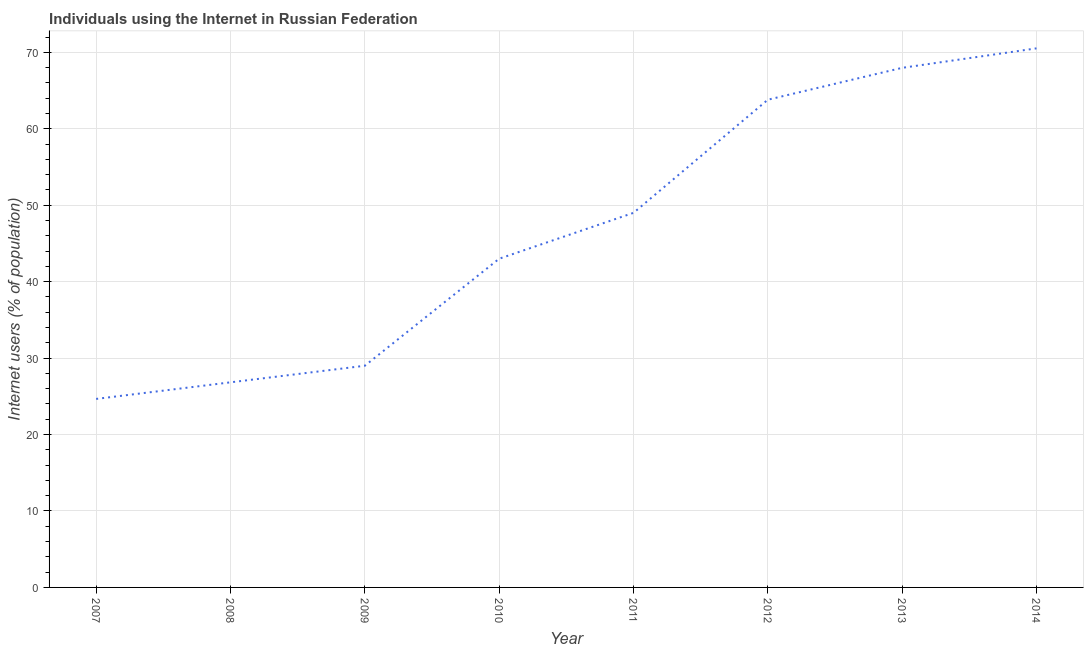What is the number of internet users in 2012?
Offer a very short reply. 63.8. Across all years, what is the maximum number of internet users?
Your answer should be very brief. 70.52. Across all years, what is the minimum number of internet users?
Make the answer very short. 24.66. In which year was the number of internet users maximum?
Ensure brevity in your answer.  2014. What is the sum of the number of internet users?
Provide a short and direct response. 374.78. What is the difference between the number of internet users in 2008 and 2011?
Offer a very short reply. -22.17. What is the average number of internet users per year?
Keep it short and to the point. 46.85. What is the ratio of the number of internet users in 2010 to that in 2011?
Give a very brief answer. 0.88. Is the number of internet users in 2009 less than that in 2010?
Make the answer very short. Yes. Is the difference between the number of internet users in 2009 and 2011 greater than the difference between any two years?
Your answer should be very brief. No. What is the difference between the highest and the second highest number of internet users?
Make the answer very short. 2.55. What is the difference between the highest and the lowest number of internet users?
Offer a terse response. 45.86. Does the number of internet users monotonically increase over the years?
Ensure brevity in your answer.  Yes. How many years are there in the graph?
Provide a succinct answer. 8. What is the difference between two consecutive major ticks on the Y-axis?
Offer a very short reply. 10. Does the graph contain any zero values?
Provide a succinct answer. No. Does the graph contain grids?
Your answer should be very brief. Yes. What is the title of the graph?
Provide a short and direct response. Individuals using the Internet in Russian Federation. What is the label or title of the Y-axis?
Your answer should be very brief. Internet users (% of population). What is the Internet users (% of population) in 2007?
Keep it short and to the point. 24.66. What is the Internet users (% of population) of 2008?
Make the answer very short. 26.83. What is the Internet users (% of population) of 2009?
Keep it short and to the point. 29. What is the Internet users (% of population) in 2010?
Ensure brevity in your answer.  43. What is the Internet users (% of population) in 2011?
Offer a very short reply. 49. What is the Internet users (% of population) in 2012?
Ensure brevity in your answer.  63.8. What is the Internet users (% of population) in 2013?
Make the answer very short. 67.97. What is the Internet users (% of population) of 2014?
Provide a short and direct response. 70.52. What is the difference between the Internet users (% of population) in 2007 and 2008?
Offer a very short reply. -2.17. What is the difference between the Internet users (% of population) in 2007 and 2009?
Provide a short and direct response. -4.34. What is the difference between the Internet users (% of population) in 2007 and 2010?
Keep it short and to the point. -18.34. What is the difference between the Internet users (% of population) in 2007 and 2011?
Give a very brief answer. -24.34. What is the difference between the Internet users (% of population) in 2007 and 2012?
Provide a succinct answer. -39.14. What is the difference between the Internet users (% of population) in 2007 and 2013?
Your answer should be compact. -43.31. What is the difference between the Internet users (% of population) in 2007 and 2014?
Make the answer very short. -45.86. What is the difference between the Internet users (% of population) in 2008 and 2009?
Offer a terse response. -2.17. What is the difference between the Internet users (% of population) in 2008 and 2010?
Your response must be concise. -16.17. What is the difference between the Internet users (% of population) in 2008 and 2011?
Provide a succinct answer. -22.17. What is the difference between the Internet users (% of population) in 2008 and 2012?
Your answer should be compact. -36.97. What is the difference between the Internet users (% of population) in 2008 and 2013?
Your response must be concise. -41.14. What is the difference between the Internet users (% of population) in 2008 and 2014?
Make the answer very short. -43.69. What is the difference between the Internet users (% of population) in 2009 and 2010?
Provide a succinct answer. -14. What is the difference between the Internet users (% of population) in 2009 and 2012?
Keep it short and to the point. -34.8. What is the difference between the Internet users (% of population) in 2009 and 2013?
Provide a short and direct response. -38.97. What is the difference between the Internet users (% of population) in 2009 and 2014?
Your response must be concise. -41.52. What is the difference between the Internet users (% of population) in 2010 and 2012?
Offer a terse response. -20.8. What is the difference between the Internet users (% of population) in 2010 and 2013?
Your answer should be very brief. -24.97. What is the difference between the Internet users (% of population) in 2010 and 2014?
Offer a terse response. -27.52. What is the difference between the Internet users (% of population) in 2011 and 2012?
Your answer should be very brief. -14.8. What is the difference between the Internet users (% of population) in 2011 and 2013?
Provide a short and direct response. -18.97. What is the difference between the Internet users (% of population) in 2011 and 2014?
Give a very brief answer. -21.52. What is the difference between the Internet users (% of population) in 2012 and 2013?
Offer a terse response. -4.17. What is the difference between the Internet users (% of population) in 2012 and 2014?
Offer a terse response. -6.72. What is the difference between the Internet users (% of population) in 2013 and 2014?
Give a very brief answer. -2.55. What is the ratio of the Internet users (% of population) in 2007 to that in 2008?
Provide a short and direct response. 0.92. What is the ratio of the Internet users (% of population) in 2007 to that in 2009?
Ensure brevity in your answer.  0.85. What is the ratio of the Internet users (% of population) in 2007 to that in 2010?
Your answer should be compact. 0.57. What is the ratio of the Internet users (% of population) in 2007 to that in 2011?
Offer a terse response. 0.5. What is the ratio of the Internet users (% of population) in 2007 to that in 2012?
Offer a very short reply. 0.39. What is the ratio of the Internet users (% of population) in 2007 to that in 2013?
Your answer should be very brief. 0.36. What is the ratio of the Internet users (% of population) in 2008 to that in 2009?
Provide a succinct answer. 0.93. What is the ratio of the Internet users (% of population) in 2008 to that in 2010?
Offer a very short reply. 0.62. What is the ratio of the Internet users (% of population) in 2008 to that in 2011?
Provide a succinct answer. 0.55. What is the ratio of the Internet users (% of population) in 2008 to that in 2012?
Provide a short and direct response. 0.42. What is the ratio of the Internet users (% of population) in 2008 to that in 2013?
Give a very brief answer. 0.4. What is the ratio of the Internet users (% of population) in 2008 to that in 2014?
Provide a short and direct response. 0.38. What is the ratio of the Internet users (% of population) in 2009 to that in 2010?
Your answer should be compact. 0.67. What is the ratio of the Internet users (% of population) in 2009 to that in 2011?
Give a very brief answer. 0.59. What is the ratio of the Internet users (% of population) in 2009 to that in 2012?
Offer a very short reply. 0.46. What is the ratio of the Internet users (% of population) in 2009 to that in 2013?
Ensure brevity in your answer.  0.43. What is the ratio of the Internet users (% of population) in 2009 to that in 2014?
Your answer should be compact. 0.41. What is the ratio of the Internet users (% of population) in 2010 to that in 2011?
Make the answer very short. 0.88. What is the ratio of the Internet users (% of population) in 2010 to that in 2012?
Ensure brevity in your answer.  0.67. What is the ratio of the Internet users (% of population) in 2010 to that in 2013?
Give a very brief answer. 0.63. What is the ratio of the Internet users (% of population) in 2010 to that in 2014?
Keep it short and to the point. 0.61. What is the ratio of the Internet users (% of population) in 2011 to that in 2012?
Your answer should be compact. 0.77. What is the ratio of the Internet users (% of population) in 2011 to that in 2013?
Offer a terse response. 0.72. What is the ratio of the Internet users (% of population) in 2011 to that in 2014?
Give a very brief answer. 0.69. What is the ratio of the Internet users (% of population) in 2012 to that in 2013?
Offer a very short reply. 0.94. What is the ratio of the Internet users (% of population) in 2012 to that in 2014?
Make the answer very short. 0.91. 